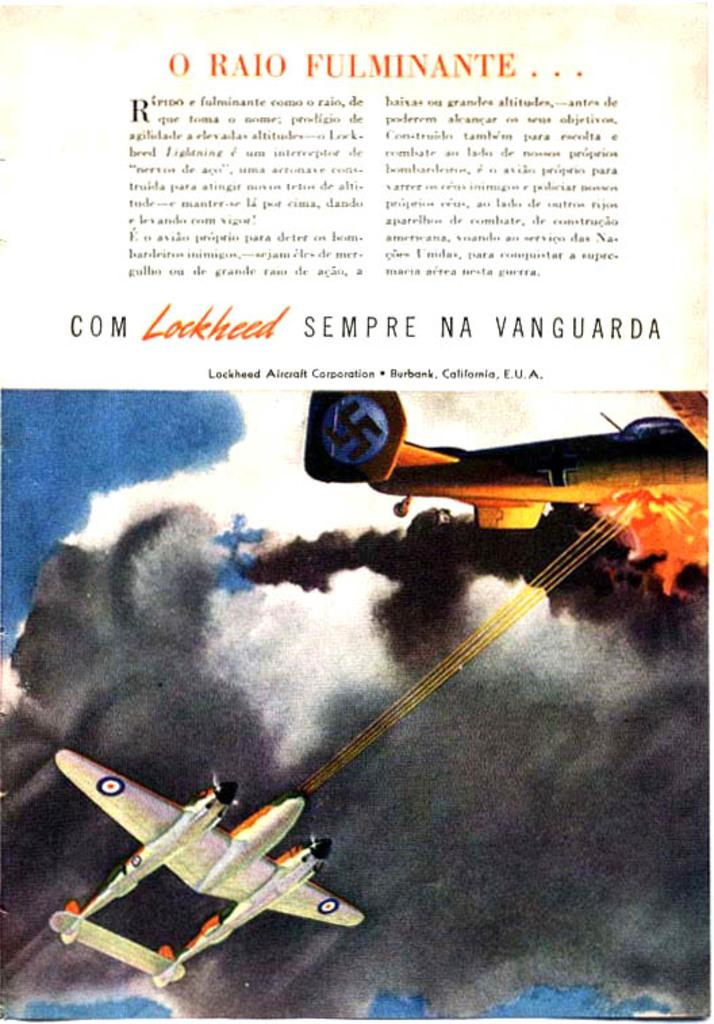What is the main subject of the picture? The main subject of the picture is a cartoon image of airplanes. What can be seen in the background of the image? The sky is visible in the picture. Are there any words or letters on the image? Yes, there is text written on the image. How many flowers are in the garden depicted in the image? There is no garden depicted in the image; it features a cartoon image of airplanes and text. 